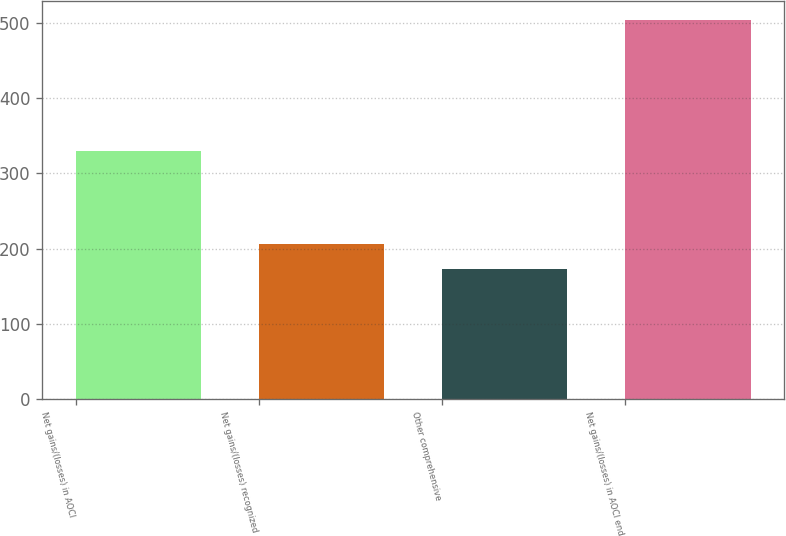Convert chart. <chart><loc_0><loc_0><loc_500><loc_500><bar_chart><fcel>Net gains/(losses) in AOCI<fcel>Net gains/(losses) recognized<fcel>Other comprehensive<fcel>Net gains/(losses) in AOCI end<nl><fcel>330.3<fcel>206.03<fcel>173<fcel>503.3<nl></chart> 